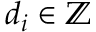<formula> <loc_0><loc_0><loc_500><loc_500>d _ { i } \in \mathbb { Z }</formula> 